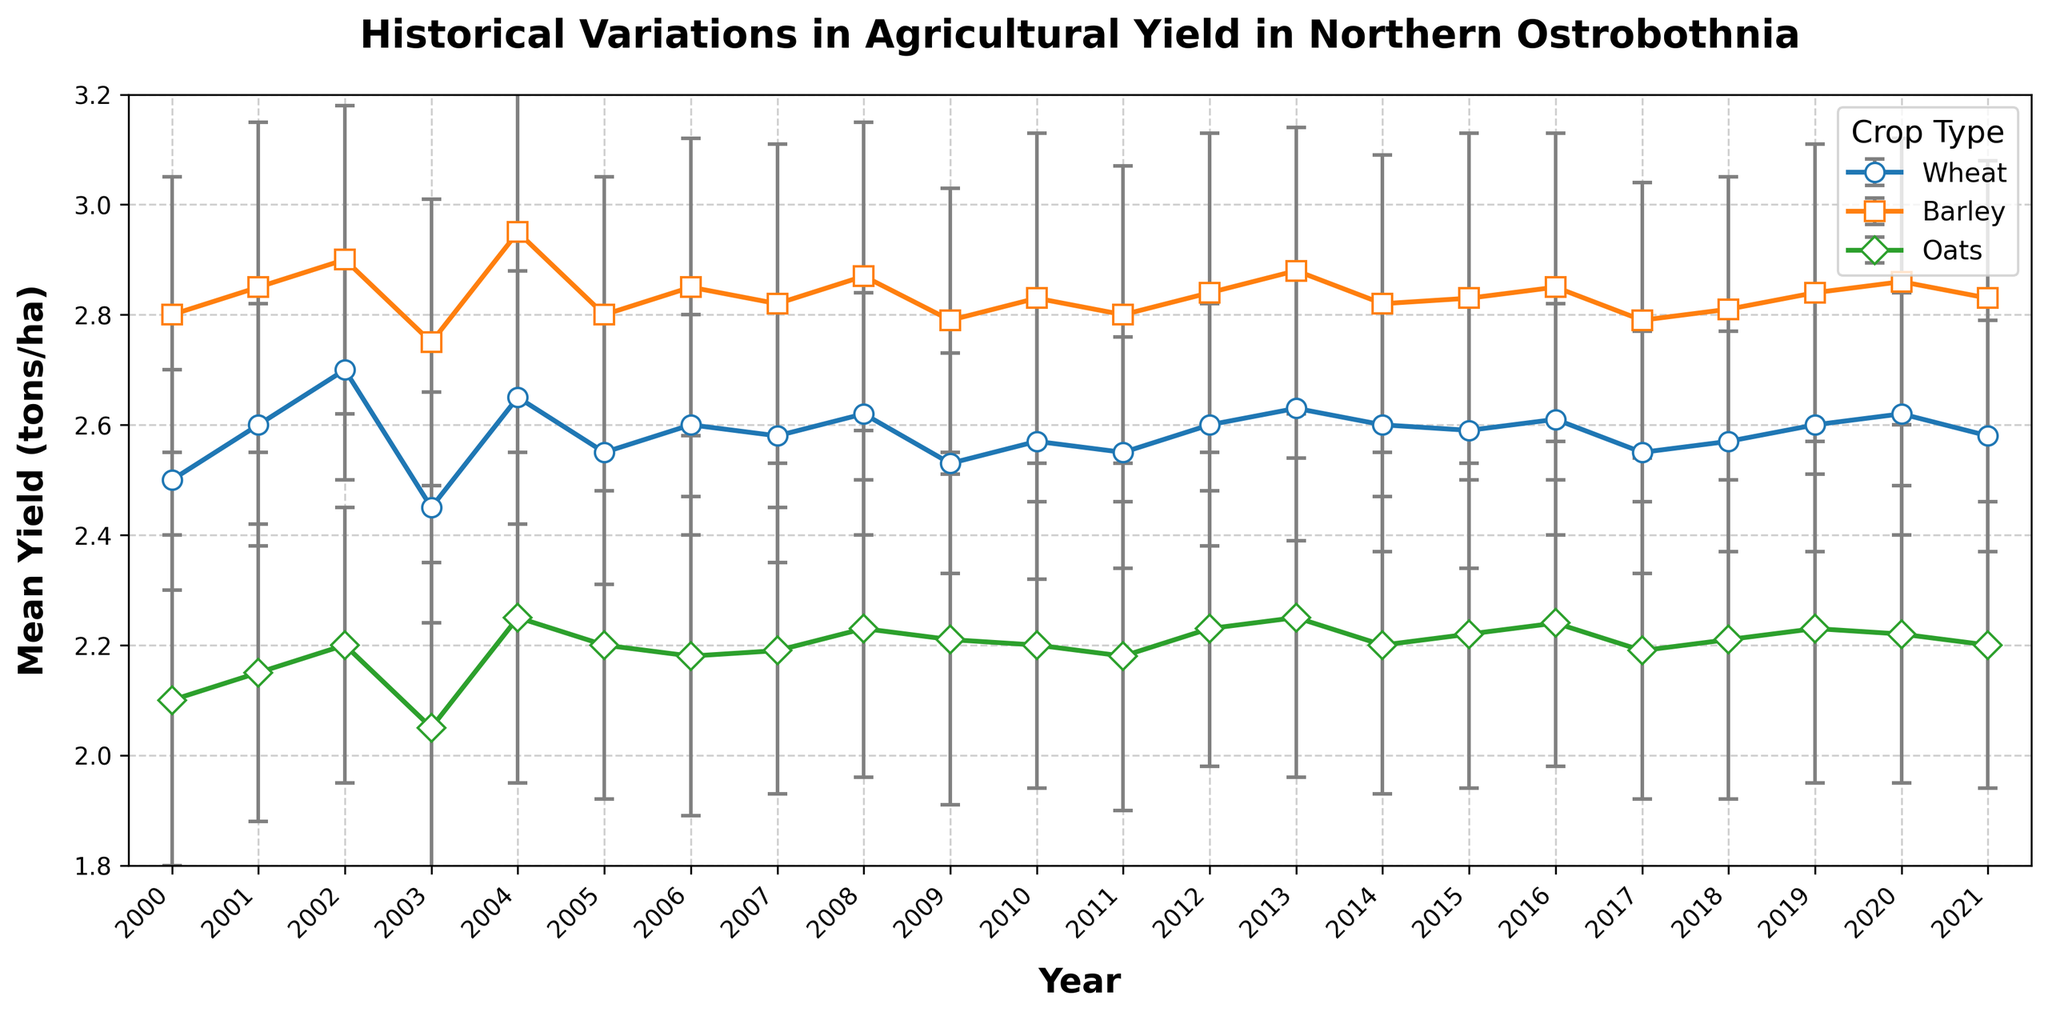What was the mean yield of barley in 2005? Examine the graph at the year 2005. Look for the data point corresponding to barley, identified by its distinct marker and color for that crop. Check the numerical value indicated by the height of the data point.
Answer: 2.8 tons/ha Which crop had the highest mean yield in 2007, and what was the value? Find the year 2007 on the x-axis and compare the heights of the data points for wheat, barley, and oats. Identify the tallest data point and note the corresponding crop type and its yield value.
Answer: Barley, 2.82 tons/ha Are there any years where all three crops show a decrease in mean yield compared to the previous year? If so, which years? Look at the year-over-year changes for wheat, barley, and oats. Check if all three crops show a drop in their yield sequentially from one year to the next across all years presented.
Answer: 2003 Between 2008 and 2012, which crop had the most consistent yield, and how can we tell? Examine the error bars for each crop from 2008 to 2012. The most consistent yield will have the smallest length of error bars over the period. Calculate the average error bar length for each crop over these years.
Answer: Wheat How does the mean yield trend for wheat from 2015 to 2020 compare with the trend for oats in the same period? Identify the data points for wheat and oats from 2015 to 2020. Observe the direction and steepness of the trends for visualization insight. Note whether the lines are rising, falling, or stable, and compare them.
Answer: Wheat shows a slight increase, while oats remain mostly stable Was there a year where the mean yield difference between barley and oats was the most significant? If so, what was the value? Compare the mean yields of barley and oats for each year and calculate the differences. Identify the year with the highest absolute difference.
Answer: 2004, 0.7 tons/ha In 2019, was the mean yield of oats higher or lower than in 2010? By how much? Locate the data points for oats for the years 2019 and 2010. Note the yield values and subtract the 2010 value from the 2019 value to find the difference.
Answer: Higher, by 0.02 tons/ha What was the average mean yield of wheat over the entire period covered in the graph? Add the mean yields of wheat for all years and divide by the total number of years to find the average.
Answer: 2.587 tons/ha Which crop had the largest error bar in 2010 and what was its value? Examine the error bars for each crop in 2010. Compare their lengths and determine which is the largest.
Answer: Wheat, 0.25 tons/ha Compare the mean yields and standard deviations of barley and oats in 2012. Which crop had a higher yield, and which had higher variability? Find the data points for barley and oats in 2012. Compare their mean yields and standard deviations to determine which is higher for yield and variability respectively.
Answer: Barley had higher yield, Oats had higher variability 